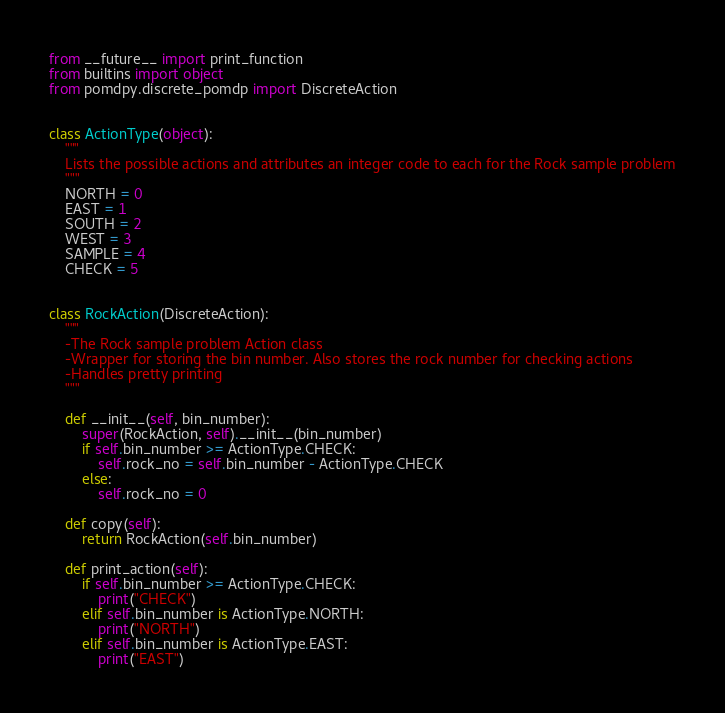<code> <loc_0><loc_0><loc_500><loc_500><_Python_>from __future__ import print_function
from builtins import object
from pomdpy.discrete_pomdp import DiscreteAction


class ActionType(object):
    """
    Lists the possible actions and attributes an integer code to each for the Rock sample problem
    """
    NORTH = 0
    EAST = 1
    SOUTH = 2
    WEST = 3
    SAMPLE = 4
    CHECK = 5


class RockAction(DiscreteAction):
    """
    -The Rock sample problem Action class
    -Wrapper for storing the bin number. Also stores the rock number for checking actions
    -Handles pretty printing
    """

    def __init__(self, bin_number):
        super(RockAction, self).__init__(bin_number)
        if self.bin_number >= ActionType.CHECK:
            self.rock_no = self.bin_number - ActionType.CHECK
        else:
            self.rock_no = 0

    def copy(self):
        return RockAction(self.bin_number)

    def print_action(self):
        if self.bin_number >= ActionType.CHECK:
            print("CHECK")
        elif self.bin_number is ActionType.NORTH:
            print("NORTH")
        elif self.bin_number is ActionType.EAST:
            print("EAST")</code> 